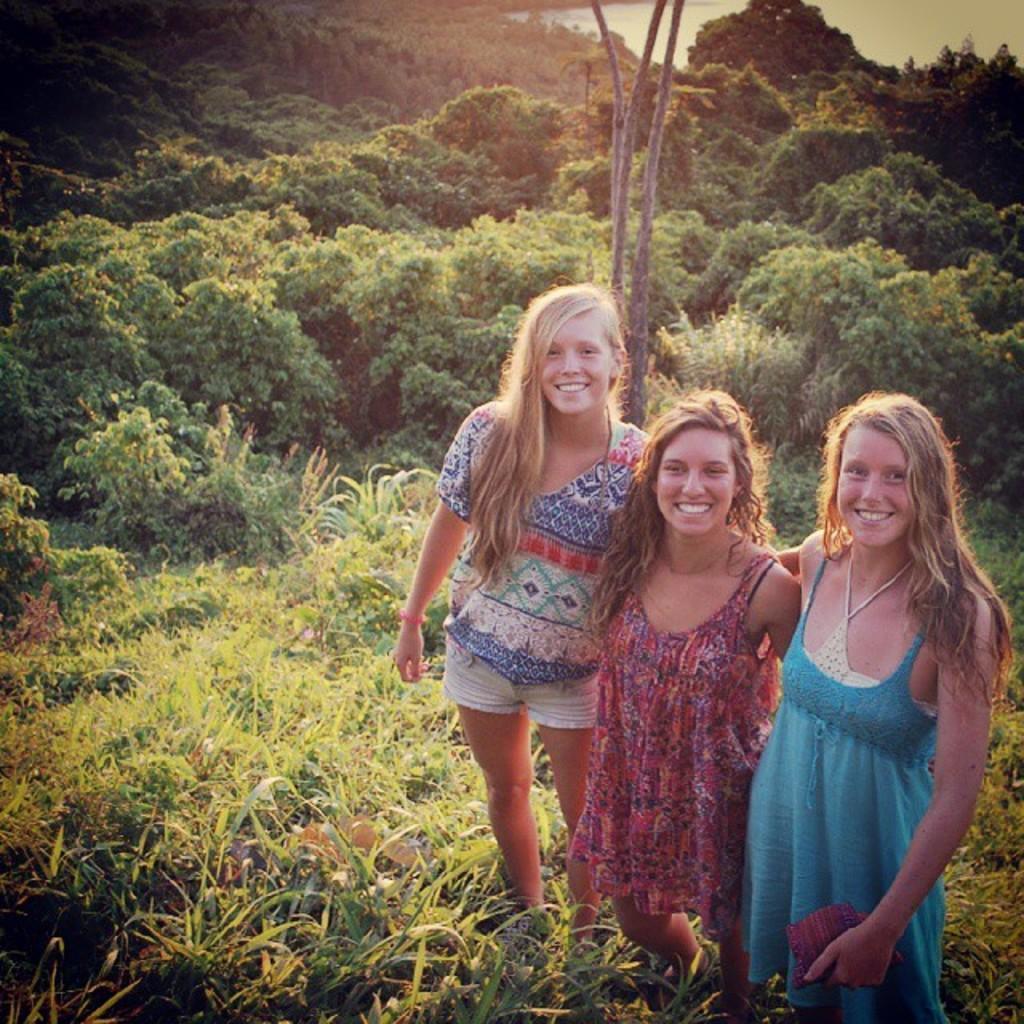Could you give a brief overview of what you see in this image? In the image there are three ladies standing on grassland and behind there are trees. 